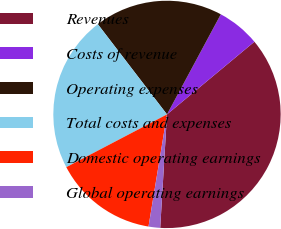<chart> <loc_0><loc_0><loc_500><loc_500><pie_chart><fcel>Revenues<fcel>Costs of revenue<fcel>Operating expenses<fcel>Total costs and expenses<fcel>Domestic operating earnings<fcel>Global operating earnings<nl><fcel>36.99%<fcel>6.11%<fcel>18.26%<fcel>22.27%<fcel>14.72%<fcel>1.65%<nl></chart> 